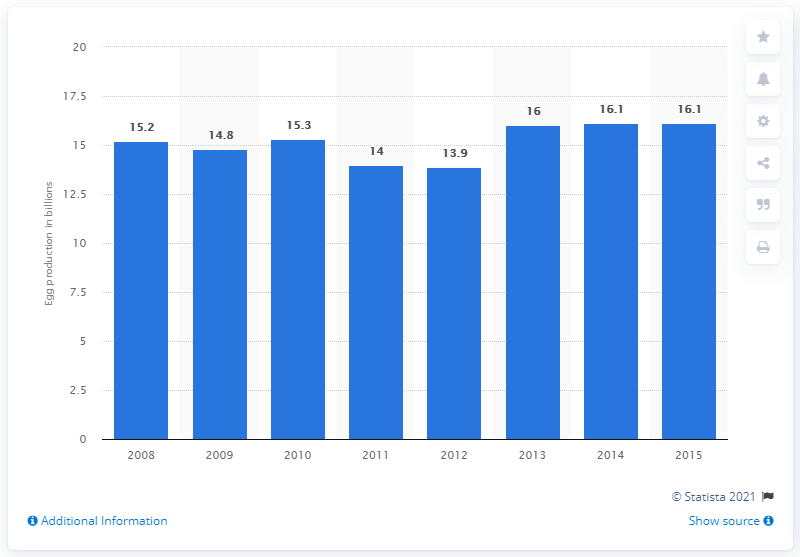Mention a couple of crucial points in this snapshot. In 2013, the total production of chicken eggs in France was 16.1 million. In 2008, the total production of chicken eggs in France was 15.3 million. 